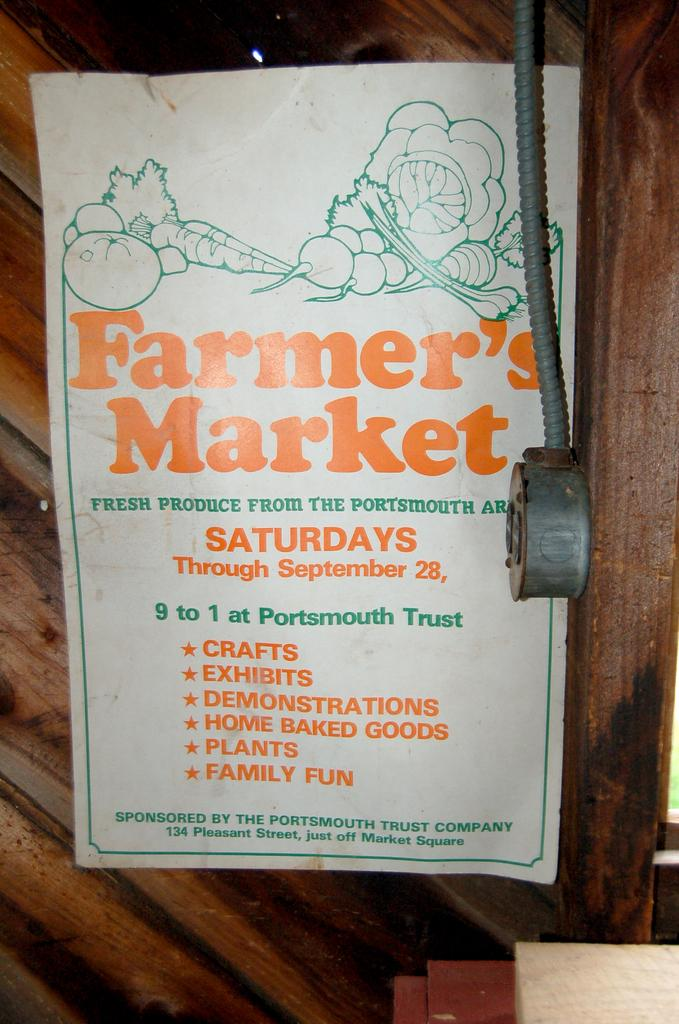What is present on the wall in the image? There is a poster in the image. What can be seen on the poster? The poster has images and text. What type of wall is the poster attached to? The poster is attached to a wooden wall. Can you describe any other objects in the image? There are a few objects in the image. How many flowers are on the poster in the image? There are no flowers present on the poster in the image. Is there a light bulb hanging from the ceiling in the image? There is no light bulb visible in the image. 